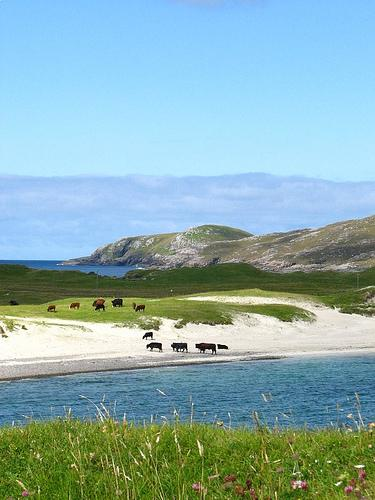How would they transport the cattle to the nearest patch of grass? boat 